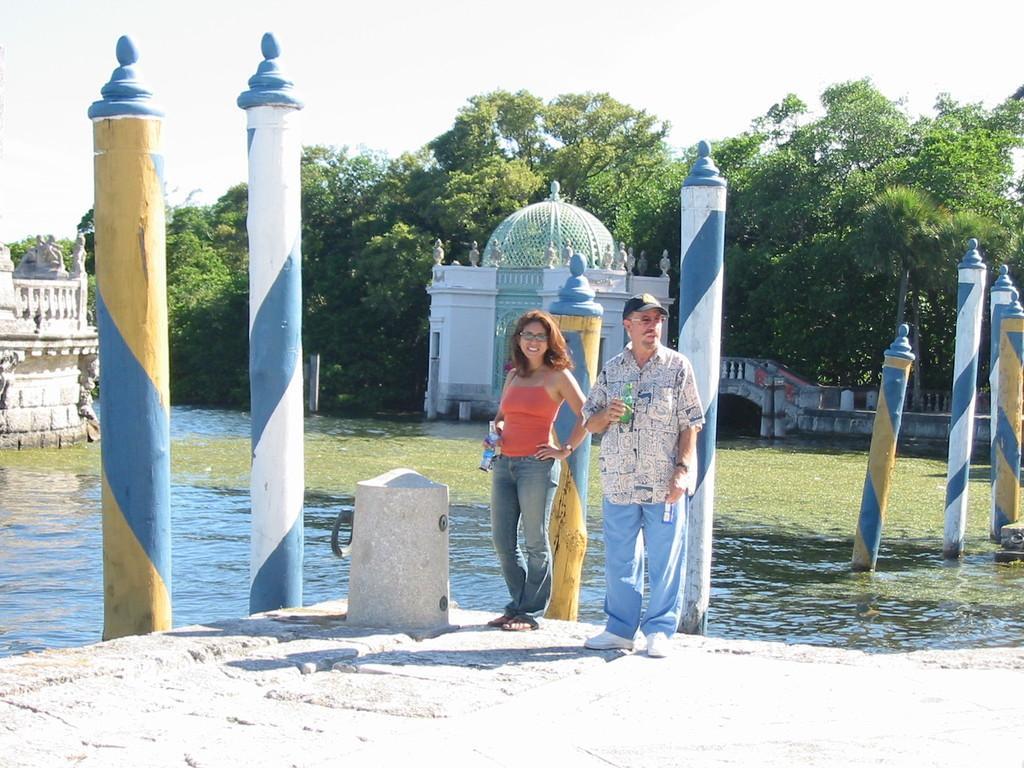Please provide a concise description of this image. In the foreground of the picture there are poles, cement platform, people and other objects. In the middle of the picture there is a water body. In the background there are trees and some constructions. At the top there is sky. 